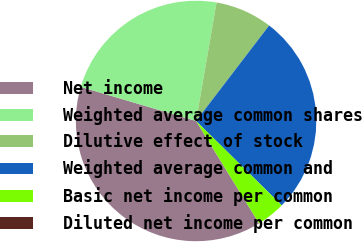Convert chart to OTSL. <chart><loc_0><loc_0><loc_500><loc_500><pie_chart><fcel>Net income<fcel>Weighted average common shares<fcel>Dilutive effect of stock<fcel>Weighted average common and<fcel>Basic net income per common<fcel>Diluted net income per common<nl><fcel>38.36%<fcel>23.15%<fcel>7.67%<fcel>26.99%<fcel>3.84%<fcel>0.0%<nl></chart> 